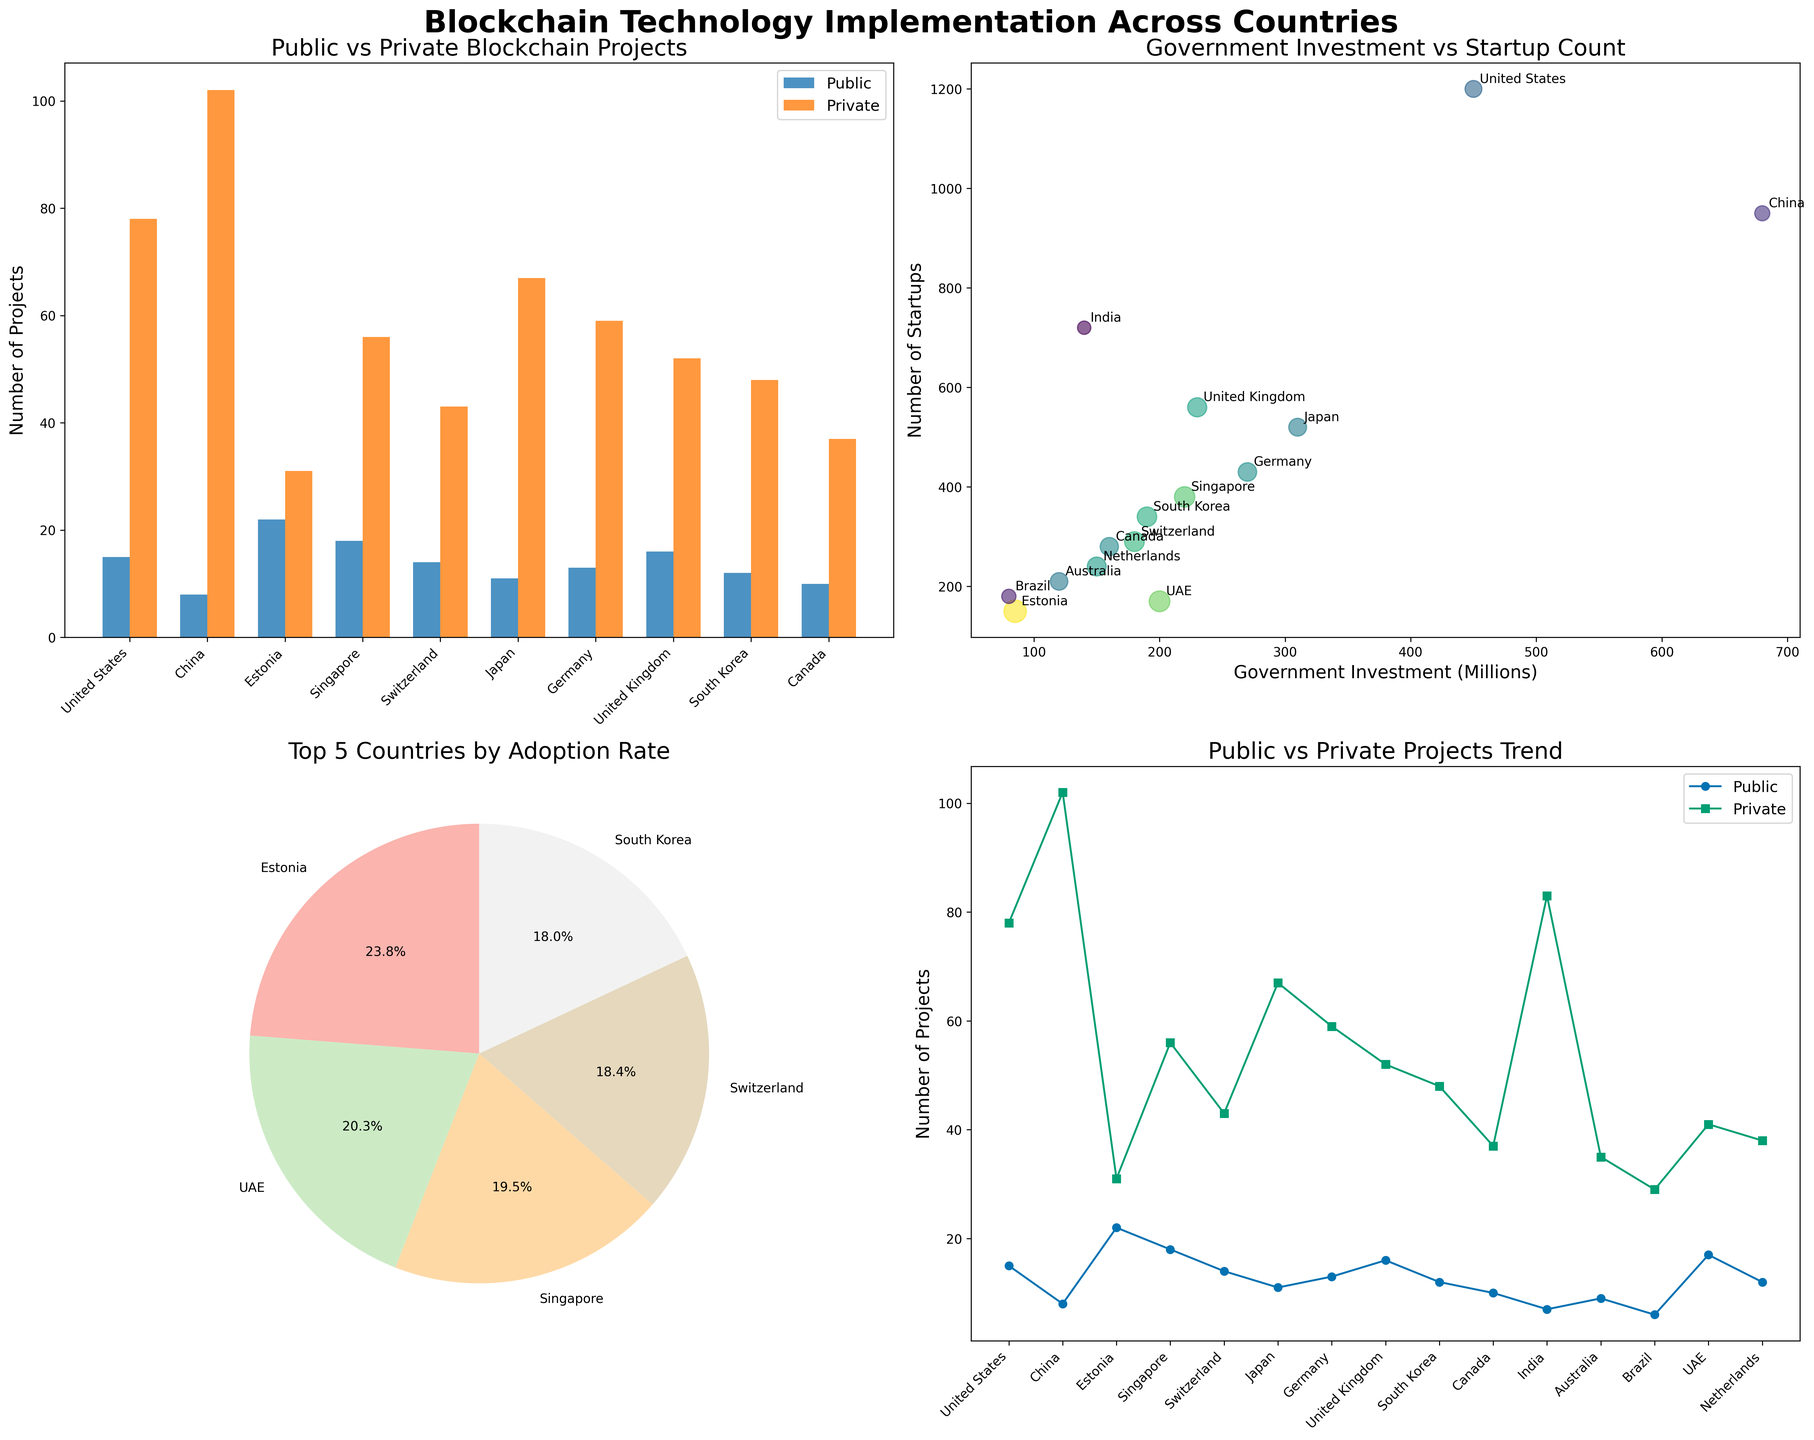What is the title of the entire figure? The title is positioned at the top of the figure and indicates the main topic of the plots. It provides an overview of what the figure depicts.
Answer: Blockchain Technology Implementation Across Countries How many countries are shown in the bar chart comparing public and private blockchain projects? The countries are listed on the x-axis of the bar chart comparing public and private blockchain projects. Count the number of countries.
Answer: 10 Which country has the most public blockchain projects according to the bar chart? Identify the bar in the chart with the greatest height in the "Public" category. The country corresponding to this bar has the most public blockchain projects.
Answer: Estonia What are the labels of the top 5 countries by adoption rate in the pie chart? Examine the labels around the pie chart. Identify the top 5 countries by adoption rate as indicated by the segments of the pie chart.
Answer: Estonia, Singapore, UAE, Switzerland, South Korea How does the number of blockchain startups correlate with government investment? Examine the scatter plot where the x-axis represents government investment and the y-axis represents the number of startups. Observe the general trend of the data points to conclude the correlation.
Answer: Positive correlation Which two countries have the closest number of public blockchain projects as per the line plot? Inspect the line plot showing public blockchain projects. Identify two countries with lines closely aligned in value for the number of public blockchain projects.
Answer: Germany and Netherlands What is the government investment amount and the number of startups for China, annotated in the scatter plot? Find the point in the scatter plot corresponding to China and refer to the axes for the government investment and number of startups values annotated at that point.
Answer: 680 millions, 950 startups In the bar chart, which sector has more projects in the United States, and by how many? Compare the height of the bars representing public and private projects for the United States. Subtract the number of public projects from the number of private projects to find the difference.
Answer: Private sector by 63 projects What is the adoption rate of the country with the least number of public blockchain projects? Locate the country with the smallest bar under the "Public" category. Refer to the adoption rate associated with this country in the dataset.
Answer: Brazil, 0.25 In the line plot, which country shows the greatest difference between public and private blockchain projects? Compare the lines representing public and private projects for each country. Identify the country with the largest vertical gap between the two lines.
Answer: China 